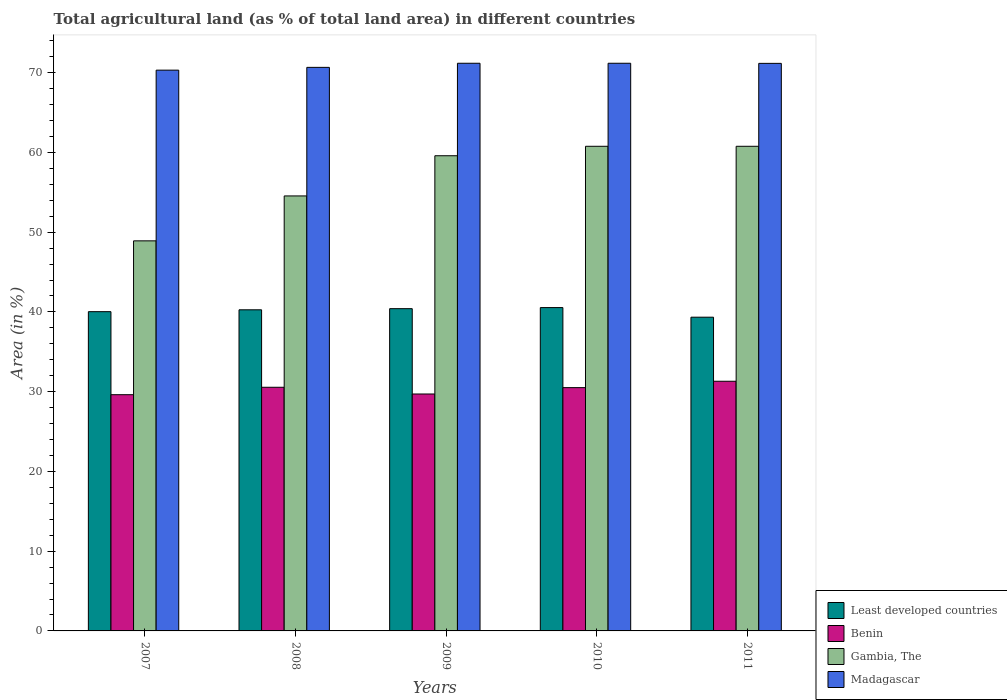How many different coloured bars are there?
Provide a succinct answer. 4. How many groups of bars are there?
Your answer should be compact. 5. Are the number of bars per tick equal to the number of legend labels?
Keep it short and to the point. Yes. Are the number of bars on each tick of the X-axis equal?
Your response must be concise. Yes. How many bars are there on the 3rd tick from the left?
Provide a short and direct response. 4. In how many cases, is the number of bars for a given year not equal to the number of legend labels?
Ensure brevity in your answer.  0. What is the percentage of agricultural land in Madagascar in 2007?
Give a very brief answer. 70.32. Across all years, what is the maximum percentage of agricultural land in Least developed countries?
Provide a short and direct response. 40.54. Across all years, what is the minimum percentage of agricultural land in Least developed countries?
Your response must be concise. 39.34. In which year was the percentage of agricultural land in Gambia, The maximum?
Your response must be concise. 2010. What is the total percentage of agricultural land in Least developed countries in the graph?
Give a very brief answer. 200.59. What is the difference between the percentage of agricultural land in Benin in 2007 and that in 2011?
Give a very brief answer. -1.68. What is the difference between the percentage of agricultural land in Gambia, The in 2011 and the percentage of agricultural land in Least developed countries in 2010?
Offer a very short reply. 20.23. What is the average percentage of agricultural land in Benin per year?
Keep it short and to the point. 30.34. In the year 2011, what is the difference between the percentage of agricultural land in Least developed countries and percentage of agricultural land in Madagascar?
Your answer should be compact. -31.83. What is the ratio of the percentage of agricultural land in Least developed countries in 2008 to that in 2011?
Offer a very short reply. 1.02. Is the percentage of agricultural land in Gambia, The in 2009 less than that in 2011?
Provide a succinct answer. Yes. Is the difference between the percentage of agricultural land in Least developed countries in 2008 and 2009 greater than the difference between the percentage of agricultural land in Madagascar in 2008 and 2009?
Provide a short and direct response. Yes. What is the difference between the highest and the second highest percentage of agricultural land in Benin?
Give a very brief answer. 0.75. What is the difference between the highest and the lowest percentage of agricultural land in Madagascar?
Make the answer very short. 0.86. In how many years, is the percentage of agricultural land in Gambia, The greater than the average percentage of agricultural land in Gambia, The taken over all years?
Your answer should be very brief. 3. What does the 4th bar from the left in 2009 represents?
Your response must be concise. Madagascar. What does the 1st bar from the right in 2007 represents?
Provide a succinct answer. Madagascar. Is it the case that in every year, the sum of the percentage of agricultural land in Madagascar and percentage of agricultural land in Least developed countries is greater than the percentage of agricultural land in Benin?
Make the answer very short. Yes. Are all the bars in the graph horizontal?
Give a very brief answer. No. How many years are there in the graph?
Provide a succinct answer. 5. What is the difference between two consecutive major ticks on the Y-axis?
Provide a short and direct response. 10. Are the values on the major ticks of Y-axis written in scientific E-notation?
Offer a very short reply. No. What is the title of the graph?
Your answer should be very brief. Total agricultural land (as % of total land area) in different countries. Does "Micronesia" appear as one of the legend labels in the graph?
Provide a short and direct response. No. What is the label or title of the X-axis?
Make the answer very short. Years. What is the label or title of the Y-axis?
Your answer should be very brief. Area (in %). What is the Area (in %) in Least developed countries in 2007?
Your answer should be very brief. 40.03. What is the Area (in %) of Benin in 2007?
Keep it short and to the point. 29.62. What is the Area (in %) of Gambia, The in 2007?
Offer a very short reply. 48.91. What is the Area (in %) in Madagascar in 2007?
Keep it short and to the point. 70.32. What is the Area (in %) of Least developed countries in 2008?
Provide a succinct answer. 40.27. What is the Area (in %) of Benin in 2008?
Keep it short and to the point. 30.55. What is the Area (in %) of Gambia, The in 2008?
Make the answer very short. 54.55. What is the Area (in %) of Madagascar in 2008?
Your response must be concise. 70.67. What is the Area (in %) in Least developed countries in 2009?
Your answer should be compact. 40.41. What is the Area (in %) of Benin in 2009?
Ensure brevity in your answer.  29.71. What is the Area (in %) in Gambia, The in 2009?
Provide a short and direct response. 59.58. What is the Area (in %) in Madagascar in 2009?
Provide a succinct answer. 71.18. What is the Area (in %) in Least developed countries in 2010?
Ensure brevity in your answer.  40.54. What is the Area (in %) of Benin in 2010?
Your response must be concise. 30.51. What is the Area (in %) of Gambia, The in 2010?
Offer a very short reply. 60.77. What is the Area (in %) of Madagascar in 2010?
Make the answer very short. 71.18. What is the Area (in %) in Least developed countries in 2011?
Make the answer very short. 39.34. What is the Area (in %) in Benin in 2011?
Make the answer very short. 31.31. What is the Area (in %) of Gambia, The in 2011?
Ensure brevity in your answer.  60.77. What is the Area (in %) of Madagascar in 2011?
Offer a very short reply. 71.17. Across all years, what is the maximum Area (in %) of Least developed countries?
Your answer should be very brief. 40.54. Across all years, what is the maximum Area (in %) of Benin?
Provide a short and direct response. 31.31. Across all years, what is the maximum Area (in %) in Gambia, The?
Give a very brief answer. 60.77. Across all years, what is the maximum Area (in %) in Madagascar?
Your response must be concise. 71.18. Across all years, what is the minimum Area (in %) of Least developed countries?
Make the answer very short. 39.34. Across all years, what is the minimum Area (in %) in Benin?
Your response must be concise. 29.62. Across all years, what is the minimum Area (in %) in Gambia, The?
Provide a short and direct response. 48.91. Across all years, what is the minimum Area (in %) in Madagascar?
Your answer should be very brief. 70.32. What is the total Area (in %) of Least developed countries in the graph?
Your answer should be compact. 200.59. What is the total Area (in %) of Benin in the graph?
Provide a succinct answer. 151.69. What is the total Area (in %) in Gambia, The in the graph?
Keep it short and to the point. 284.58. What is the total Area (in %) of Madagascar in the graph?
Offer a very short reply. 354.52. What is the difference between the Area (in %) of Least developed countries in 2007 and that in 2008?
Offer a terse response. -0.23. What is the difference between the Area (in %) of Benin in 2007 and that in 2008?
Make the answer very short. -0.93. What is the difference between the Area (in %) in Gambia, The in 2007 and that in 2008?
Provide a short and direct response. -5.63. What is the difference between the Area (in %) in Madagascar in 2007 and that in 2008?
Offer a terse response. -0.35. What is the difference between the Area (in %) in Least developed countries in 2007 and that in 2009?
Keep it short and to the point. -0.37. What is the difference between the Area (in %) in Benin in 2007 and that in 2009?
Your answer should be very brief. -0.09. What is the difference between the Area (in %) in Gambia, The in 2007 and that in 2009?
Provide a succinct answer. -10.67. What is the difference between the Area (in %) of Madagascar in 2007 and that in 2009?
Ensure brevity in your answer.  -0.86. What is the difference between the Area (in %) of Least developed countries in 2007 and that in 2010?
Give a very brief answer. -0.51. What is the difference between the Area (in %) of Benin in 2007 and that in 2010?
Provide a succinct answer. -0.89. What is the difference between the Area (in %) in Gambia, The in 2007 and that in 2010?
Give a very brief answer. -11.86. What is the difference between the Area (in %) in Madagascar in 2007 and that in 2010?
Offer a terse response. -0.86. What is the difference between the Area (in %) in Least developed countries in 2007 and that in 2011?
Your answer should be very brief. 0.69. What is the difference between the Area (in %) in Benin in 2007 and that in 2011?
Your answer should be compact. -1.69. What is the difference between the Area (in %) in Gambia, The in 2007 and that in 2011?
Offer a very short reply. -11.86. What is the difference between the Area (in %) of Madagascar in 2007 and that in 2011?
Make the answer very short. -0.85. What is the difference between the Area (in %) in Least developed countries in 2008 and that in 2009?
Ensure brevity in your answer.  -0.14. What is the difference between the Area (in %) in Benin in 2008 and that in 2009?
Provide a succinct answer. 0.84. What is the difference between the Area (in %) in Gambia, The in 2008 and that in 2009?
Keep it short and to the point. -5.04. What is the difference between the Area (in %) of Madagascar in 2008 and that in 2009?
Ensure brevity in your answer.  -0.52. What is the difference between the Area (in %) of Least developed countries in 2008 and that in 2010?
Give a very brief answer. -0.28. What is the difference between the Area (in %) in Benin in 2008 and that in 2010?
Ensure brevity in your answer.  0.04. What is the difference between the Area (in %) in Gambia, The in 2008 and that in 2010?
Your response must be concise. -6.23. What is the difference between the Area (in %) in Madagascar in 2008 and that in 2010?
Your answer should be compact. -0.52. What is the difference between the Area (in %) in Least developed countries in 2008 and that in 2011?
Offer a very short reply. 0.93. What is the difference between the Area (in %) in Benin in 2008 and that in 2011?
Offer a very short reply. -0.75. What is the difference between the Area (in %) in Gambia, The in 2008 and that in 2011?
Provide a succinct answer. -6.23. What is the difference between the Area (in %) of Madagascar in 2008 and that in 2011?
Keep it short and to the point. -0.5. What is the difference between the Area (in %) in Least developed countries in 2009 and that in 2010?
Provide a succinct answer. -0.14. What is the difference between the Area (in %) in Benin in 2009 and that in 2010?
Offer a terse response. -0.8. What is the difference between the Area (in %) in Gambia, The in 2009 and that in 2010?
Offer a very short reply. -1.19. What is the difference between the Area (in %) in Madagascar in 2009 and that in 2010?
Your answer should be compact. 0. What is the difference between the Area (in %) in Least developed countries in 2009 and that in 2011?
Give a very brief answer. 1.07. What is the difference between the Area (in %) of Benin in 2009 and that in 2011?
Your answer should be compact. -1.6. What is the difference between the Area (in %) of Gambia, The in 2009 and that in 2011?
Offer a very short reply. -1.19. What is the difference between the Area (in %) in Madagascar in 2009 and that in 2011?
Your answer should be very brief. 0.01. What is the difference between the Area (in %) in Least developed countries in 2010 and that in 2011?
Ensure brevity in your answer.  1.21. What is the difference between the Area (in %) of Benin in 2010 and that in 2011?
Make the answer very short. -0.8. What is the difference between the Area (in %) in Gambia, The in 2010 and that in 2011?
Make the answer very short. 0. What is the difference between the Area (in %) of Madagascar in 2010 and that in 2011?
Your answer should be compact. 0.01. What is the difference between the Area (in %) of Least developed countries in 2007 and the Area (in %) of Benin in 2008?
Offer a very short reply. 9.48. What is the difference between the Area (in %) of Least developed countries in 2007 and the Area (in %) of Gambia, The in 2008?
Offer a terse response. -14.51. What is the difference between the Area (in %) in Least developed countries in 2007 and the Area (in %) in Madagascar in 2008?
Your answer should be compact. -30.63. What is the difference between the Area (in %) in Benin in 2007 and the Area (in %) in Gambia, The in 2008?
Your response must be concise. -24.93. What is the difference between the Area (in %) in Benin in 2007 and the Area (in %) in Madagascar in 2008?
Your answer should be very brief. -41.05. What is the difference between the Area (in %) in Gambia, The in 2007 and the Area (in %) in Madagascar in 2008?
Provide a succinct answer. -21.75. What is the difference between the Area (in %) in Least developed countries in 2007 and the Area (in %) in Benin in 2009?
Your answer should be compact. 10.32. What is the difference between the Area (in %) in Least developed countries in 2007 and the Area (in %) in Gambia, The in 2009?
Provide a short and direct response. -19.55. What is the difference between the Area (in %) of Least developed countries in 2007 and the Area (in %) of Madagascar in 2009?
Keep it short and to the point. -31.15. What is the difference between the Area (in %) of Benin in 2007 and the Area (in %) of Gambia, The in 2009?
Make the answer very short. -29.96. What is the difference between the Area (in %) of Benin in 2007 and the Area (in %) of Madagascar in 2009?
Make the answer very short. -41.56. What is the difference between the Area (in %) of Gambia, The in 2007 and the Area (in %) of Madagascar in 2009?
Give a very brief answer. -22.27. What is the difference between the Area (in %) of Least developed countries in 2007 and the Area (in %) of Benin in 2010?
Give a very brief answer. 9.53. What is the difference between the Area (in %) of Least developed countries in 2007 and the Area (in %) of Gambia, The in 2010?
Offer a terse response. -20.74. What is the difference between the Area (in %) in Least developed countries in 2007 and the Area (in %) in Madagascar in 2010?
Offer a terse response. -31.15. What is the difference between the Area (in %) in Benin in 2007 and the Area (in %) in Gambia, The in 2010?
Give a very brief answer. -31.15. What is the difference between the Area (in %) in Benin in 2007 and the Area (in %) in Madagascar in 2010?
Give a very brief answer. -41.56. What is the difference between the Area (in %) in Gambia, The in 2007 and the Area (in %) in Madagascar in 2010?
Your response must be concise. -22.27. What is the difference between the Area (in %) of Least developed countries in 2007 and the Area (in %) of Benin in 2011?
Offer a terse response. 8.73. What is the difference between the Area (in %) of Least developed countries in 2007 and the Area (in %) of Gambia, The in 2011?
Your response must be concise. -20.74. What is the difference between the Area (in %) in Least developed countries in 2007 and the Area (in %) in Madagascar in 2011?
Ensure brevity in your answer.  -31.13. What is the difference between the Area (in %) of Benin in 2007 and the Area (in %) of Gambia, The in 2011?
Make the answer very short. -31.15. What is the difference between the Area (in %) of Benin in 2007 and the Area (in %) of Madagascar in 2011?
Give a very brief answer. -41.55. What is the difference between the Area (in %) of Gambia, The in 2007 and the Area (in %) of Madagascar in 2011?
Ensure brevity in your answer.  -22.25. What is the difference between the Area (in %) in Least developed countries in 2008 and the Area (in %) in Benin in 2009?
Your answer should be very brief. 10.56. What is the difference between the Area (in %) in Least developed countries in 2008 and the Area (in %) in Gambia, The in 2009?
Your answer should be compact. -19.32. What is the difference between the Area (in %) in Least developed countries in 2008 and the Area (in %) in Madagascar in 2009?
Ensure brevity in your answer.  -30.91. What is the difference between the Area (in %) of Benin in 2008 and the Area (in %) of Gambia, The in 2009?
Offer a terse response. -29.03. What is the difference between the Area (in %) of Benin in 2008 and the Area (in %) of Madagascar in 2009?
Your answer should be very brief. -40.63. What is the difference between the Area (in %) of Gambia, The in 2008 and the Area (in %) of Madagascar in 2009?
Offer a very short reply. -16.64. What is the difference between the Area (in %) in Least developed countries in 2008 and the Area (in %) in Benin in 2010?
Give a very brief answer. 9.76. What is the difference between the Area (in %) of Least developed countries in 2008 and the Area (in %) of Gambia, The in 2010?
Provide a short and direct response. -20.5. What is the difference between the Area (in %) of Least developed countries in 2008 and the Area (in %) of Madagascar in 2010?
Make the answer very short. -30.91. What is the difference between the Area (in %) of Benin in 2008 and the Area (in %) of Gambia, The in 2010?
Make the answer very short. -30.22. What is the difference between the Area (in %) in Benin in 2008 and the Area (in %) in Madagascar in 2010?
Offer a terse response. -40.63. What is the difference between the Area (in %) in Gambia, The in 2008 and the Area (in %) in Madagascar in 2010?
Offer a terse response. -16.64. What is the difference between the Area (in %) in Least developed countries in 2008 and the Area (in %) in Benin in 2011?
Your answer should be very brief. 8.96. What is the difference between the Area (in %) in Least developed countries in 2008 and the Area (in %) in Gambia, The in 2011?
Your response must be concise. -20.5. What is the difference between the Area (in %) of Least developed countries in 2008 and the Area (in %) of Madagascar in 2011?
Give a very brief answer. -30.9. What is the difference between the Area (in %) in Benin in 2008 and the Area (in %) in Gambia, The in 2011?
Your response must be concise. -30.22. What is the difference between the Area (in %) in Benin in 2008 and the Area (in %) in Madagascar in 2011?
Offer a terse response. -40.62. What is the difference between the Area (in %) of Gambia, The in 2008 and the Area (in %) of Madagascar in 2011?
Your answer should be compact. -16.62. What is the difference between the Area (in %) in Least developed countries in 2009 and the Area (in %) in Benin in 2010?
Ensure brevity in your answer.  9.9. What is the difference between the Area (in %) of Least developed countries in 2009 and the Area (in %) of Gambia, The in 2010?
Your answer should be compact. -20.36. What is the difference between the Area (in %) of Least developed countries in 2009 and the Area (in %) of Madagascar in 2010?
Your answer should be very brief. -30.77. What is the difference between the Area (in %) of Benin in 2009 and the Area (in %) of Gambia, The in 2010?
Ensure brevity in your answer.  -31.06. What is the difference between the Area (in %) in Benin in 2009 and the Area (in %) in Madagascar in 2010?
Provide a succinct answer. -41.47. What is the difference between the Area (in %) of Gambia, The in 2009 and the Area (in %) of Madagascar in 2010?
Keep it short and to the point. -11.6. What is the difference between the Area (in %) in Least developed countries in 2009 and the Area (in %) in Benin in 2011?
Offer a very short reply. 9.1. What is the difference between the Area (in %) of Least developed countries in 2009 and the Area (in %) of Gambia, The in 2011?
Offer a very short reply. -20.36. What is the difference between the Area (in %) in Least developed countries in 2009 and the Area (in %) in Madagascar in 2011?
Your response must be concise. -30.76. What is the difference between the Area (in %) of Benin in 2009 and the Area (in %) of Gambia, The in 2011?
Give a very brief answer. -31.06. What is the difference between the Area (in %) of Benin in 2009 and the Area (in %) of Madagascar in 2011?
Your response must be concise. -41.46. What is the difference between the Area (in %) of Gambia, The in 2009 and the Area (in %) of Madagascar in 2011?
Provide a short and direct response. -11.58. What is the difference between the Area (in %) in Least developed countries in 2010 and the Area (in %) in Benin in 2011?
Your response must be concise. 9.24. What is the difference between the Area (in %) in Least developed countries in 2010 and the Area (in %) in Gambia, The in 2011?
Offer a terse response. -20.23. What is the difference between the Area (in %) in Least developed countries in 2010 and the Area (in %) in Madagascar in 2011?
Your answer should be compact. -30.62. What is the difference between the Area (in %) in Benin in 2010 and the Area (in %) in Gambia, The in 2011?
Make the answer very short. -30.26. What is the difference between the Area (in %) in Benin in 2010 and the Area (in %) in Madagascar in 2011?
Ensure brevity in your answer.  -40.66. What is the difference between the Area (in %) of Gambia, The in 2010 and the Area (in %) of Madagascar in 2011?
Keep it short and to the point. -10.4. What is the average Area (in %) of Least developed countries per year?
Offer a very short reply. 40.12. What is the average Area (in %) of Benin per year?
Provide a short and direct response. 30.34. What is the average Area (in %) of Gambia, The per year?
Offer a terse response. 56.92. What is the average Area (in %) of Madagascar per year?
Make the answer very short. 70.9. In the year 2007, what is the difference between the Area (in %) in Least developed countries and Area (in %) in Benin?
Your response must be concise. 10.41. In the year 2007, what is the difference between the Area (in %) of Least developed countries and Area (in %) of Gambia, The?
Provide a short and direct response. -8.88. In the year 2007, what is the difference between the Area (in %) of Least developed countries and Area (in %) of Madagascar?
Offer a very short reply. -30.28. In the year 2007, what is the difference between the Area (in %) in Benin and Area (in %) in Gambia, The?
Offer a very short reply. -19.29. In the year 2007, what is the difference between the Area (in %) in Benin and Area (in %) in Madagascar?
Ensure brevity in your answer.  -40.7. In the year 2007, what is the difference between the Area (in %) in Gambia, The and Area (in %) in Madagascar?
Offer a terse response. -21.41. In the year 2008, what is the difference between the Area (in %) of Least developed countries and Area (in %) of Benin?
Make the answer very short. 9.72. In the year 2008, what is the difference between the Area (in %) in Least developed countries and Area (in %) in Gambia, The?
Provide a short and direct response. -14.28. In the year 2008, what is the difference between the Area (in %) in Least developed countries and Area (in %) in Madagascar?
Your answer should be very brief. -30.4. In the year 2008, what is the difference between the Area (in %) of Benin and Area (in %) of Gambia, The?
Your answer should be compact. -23.99. In the year 2008, what is the difference between the Area (in %) in Benin and Area (in %) in Madagascar?
Ensure brevity in your answer.  -40.11. In the year 2008, what is the difference between the Area (in %) in Gambia, The and Area (in %) in Madagascar?
Ensure brevity in your answer.  -16.12. In the year 2009, what is the difference between the Area (in %) of Least developed countries and Area (in %) of Benin?
Offer a terse response. 10.7. In the year 2009, what is the difference between the Area (in %) of Least developed countries and Area (in %) of Gambia, The?
Offer a very short reply. -19.18. In the year 2009, what is the difference between the Area (in %) in Least developed countries and Area (in %) in Madagascar?
Provide a succinct answer. -30.77. In the year 2009, what is the difference between the Area (in %) in Benin and Area (in %) in Gambia, The?
Your response must be concise. -29.88. In the year 2009, what is the difference between the Area (in %) of Benin and Area (in %) of Madagascar?
Give a very brief answer. -41.47. In the year 2009, what is the difference between the Area (in %) of Gambia, The and Area (in %) of Madagascar?
Provide a succinct answer. -11.6. In the year 2010, what is the difference between the Area (in %) of Least developed countries and Area (in %) of Benin?
Make the answer very short. 10.04. In the year 2010, what is the difference between the Area (in %) of Least developed countries and Area (in %) of Gambia, The?
Provide a short and direct response. -20.23. In the year 2010, what is the difference between the Area (in %) in Least developed countries and Area (in %) in Madagascar?
Provide a succinct answer. -30.64. In the year 2010, what is the difference between the Area (in %) of Benin and Area (in %) of Gambia, The?
Provide a succinct answer. -30.26. In the year 2010, what is the difference between the Area (in %) of Benin and Area (in %) of Madagascar?
Ensure brevity in your answer.  -40.67. In the year 2010, what is the difference between the Area (in %) in Gambia, The and Area (in %) in Madagascar?
Make the answer very short. -10.41. In the year 2011, what is the difference between the Area (in %) of Least developed countries and Area (in %) of Benin?
Ensure brevity in your answer.  8.03. In the year 2011, what is the difference between the Area (in %) of Least developed countries and Area (in %) of Gambia, The?
Your answer should be compact. -21.43. In the year 2011, what is the difference between the Area (in %) in Least developed countries and Area (in %) in Madagascar?
Your answer should be very brief. -31.83. In the year 2011, what is the difference between the Area (in %) of Benin and Area (in %) of Gambia, The?
Offer a terse response. -29.47. In the year 2011, what is the difference between the Area (in %) of Benin and Area (in %) of Madagascar?
Your response must be concise. -39.86. In the year 2011, what is the difference between the Area (in %) in Gambia, The and Area (in %) in Madagascar?
Give a very brief answer. -10.4. What is the ratio of the Area (in %) in Least developed countries in 2007 to that in 2008?
Ensure brevity in your answer.  0.99. What is the ratio of the Area (in %) of Benin in 2007 to that in 2008?
Offer a terse response. 0.97. What is the ratio of the Area (in %) of Gambia, The in 2007 to that in 2008?
Ensure brevity in your answer.  0.9. What is the ratio of the Area (in %) of Madagascar in 2007 to that in 2008?
Give a very brief answer. 1. What is the ratio of the Area (in %) in Gambia, The in 2007 to that in 2009?
Make the answer very short. 0.82. What is the ratio of the Area (in %) of Madagascar in 2007 to that in 2009?
Make the answer very short. 0.99. What is the ratio of the Area (in %) of Least developed countries in 2007 to that in 2010?
Provide a succinct answer. 0.99. What is the ratio of the Area (in %) of Benin in 2007 to that in 2010?
Your answer should be compact. 0.97. What is the ratio of the Area (in %) in Gambia, The in 2007 to that in 2010?
Your response must be concise. 0.8. What is the ratio of the Area (in %) in Madagascar in 2007 to that in 2010?
Offer a terse response. 0.99. What is the ratio of the Area (in %) in Least developed countries in 2007 to that in 2011?
Your answer should be compact. 1.02. What is the ratio of the Area (in %) in Benin in 2007 to that in 2011?
Your response must be concise. 0.95. What is the ratio of the Area (in %) of Gambia, The in 2007 to that in 2011?
Ensure brevity in your answer.  0.8. What is the ratio of the Area (in %) in Benin in 2008 to that in 2009?
Your answer should be very brief. 1.03. What is the ratio of the Area (in %) in Gambia, The in 2008 to that in 2009?
Provide a succinct answer. 0.92. What is the ratio of the Area (in %) of Least developed countries in 2008 to that in 2010?
Provide a short and direct response. 0.99. What is the ratio of the Area (in %) of Benin in 2008 to that in 2010?
Your answer should be very brief. 1. What is the ratio of the Area (in %) of Gambia, The in 2008 to that in 2010?
Your answer should be very brief. 0.9. What is the ratio of the Area (in %) in Madagascar in 2008 to that in 2010?
Your answer should be compact. 0.99. What is the ratio of the Area (in %) in Least developed countries in 2008 to that in 2011?
Make the answer very short. 1.02. What is the ratio of the Area (in %) of Benin in 2008 to that in 2011?
Offer a terse response. 0.98. What is the ratio of the Area (in %) of Gambia, The in 2008 to that in 2011?
Provide a short and direct response. 0.9. What is the ratio of the Area (in %) in Madagascar in 2008 to that in 2011?
Provide a succinct answer. 0.99. What is the ratio of the Area (in %) of Benin in 2009 to that in 2010?
Make the answer very short. 0.97. What is the ratio of the Area (in %) in Gambia, The in 2009 to that in 2010?
Provide a short and direct response. 0.98. What is the ratio of the Area (in %) in Madagascar in 2009 to that in 2010?
Give a very brief answer. 1. What is the ratio of the Area (in %) in Least developed countries in 2009 to that in 2011?
Ensure brevity in your answer.  1.03. What is the ratio of the Area (in %) of Benin in 2009 to that in 2011?
Provide a succinct answer. 0.95. What is the ratio of the Area (in %) of Gambia, The in 2009 to that in 2011?
Provide a succinct answer. 0.98. What is the ratio of the Area (in %) in Madagascar in 2009 to that in 2011?
Your answer should be compact. 1. What is the ratio of the Area (in %) of Least developed countries in 2010 to that in 2011?
Give a very brief answer. 1.03. What is the ratio of the Area (in %) of Benin in 2010 to that in 2011?
Keep it short and to the point. 0.97. What is the difference between the highest and the second highest Area (in %) of Least developed countries?
Provide a succinct answer. 0.14. What is the difference between the highest and the second highest Area (in %) of Benin?
Make the answer very short. 0.75. What is the difference between the highest and the second highest Area (in %) in Madagascar?
Keep it short and to the point. 0. What is the difference between the highest and the lowest Area (in %) of Least developed countries?
Make the answer very short. 1.21. What is the difference between the highest and the lowest Area (in %) in Benin?
Keep it short and to the point. 1.69. What is the difference between the highest and the lowest Area (in %) of Gambia, The?
Offer a very short reply. 11.86. What is the difference between the highest and the lowest Area (in %) of Madagascar?
Keep it short and to the point. 0.86. 